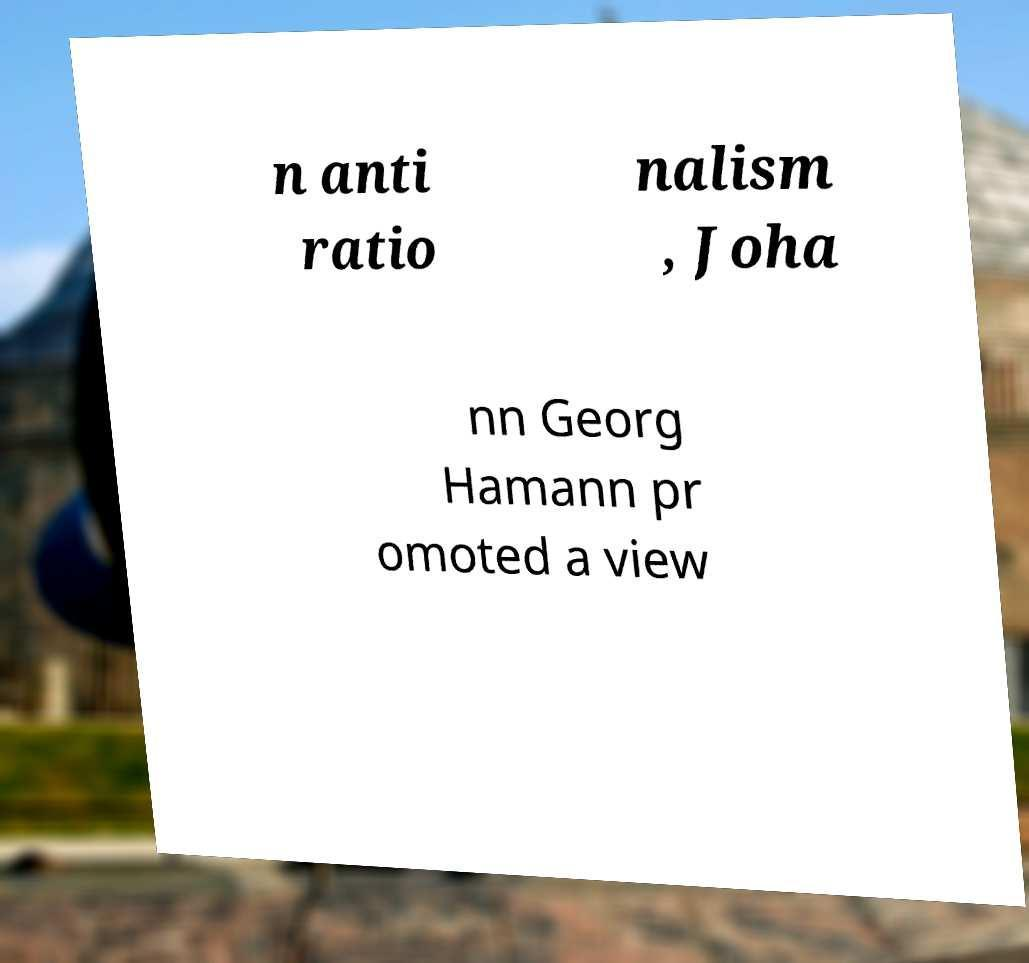Please read and relay the text visible in this image. What does it say? n anti ratio nalism , Joha nn Georg Hamann pr omoted a view 